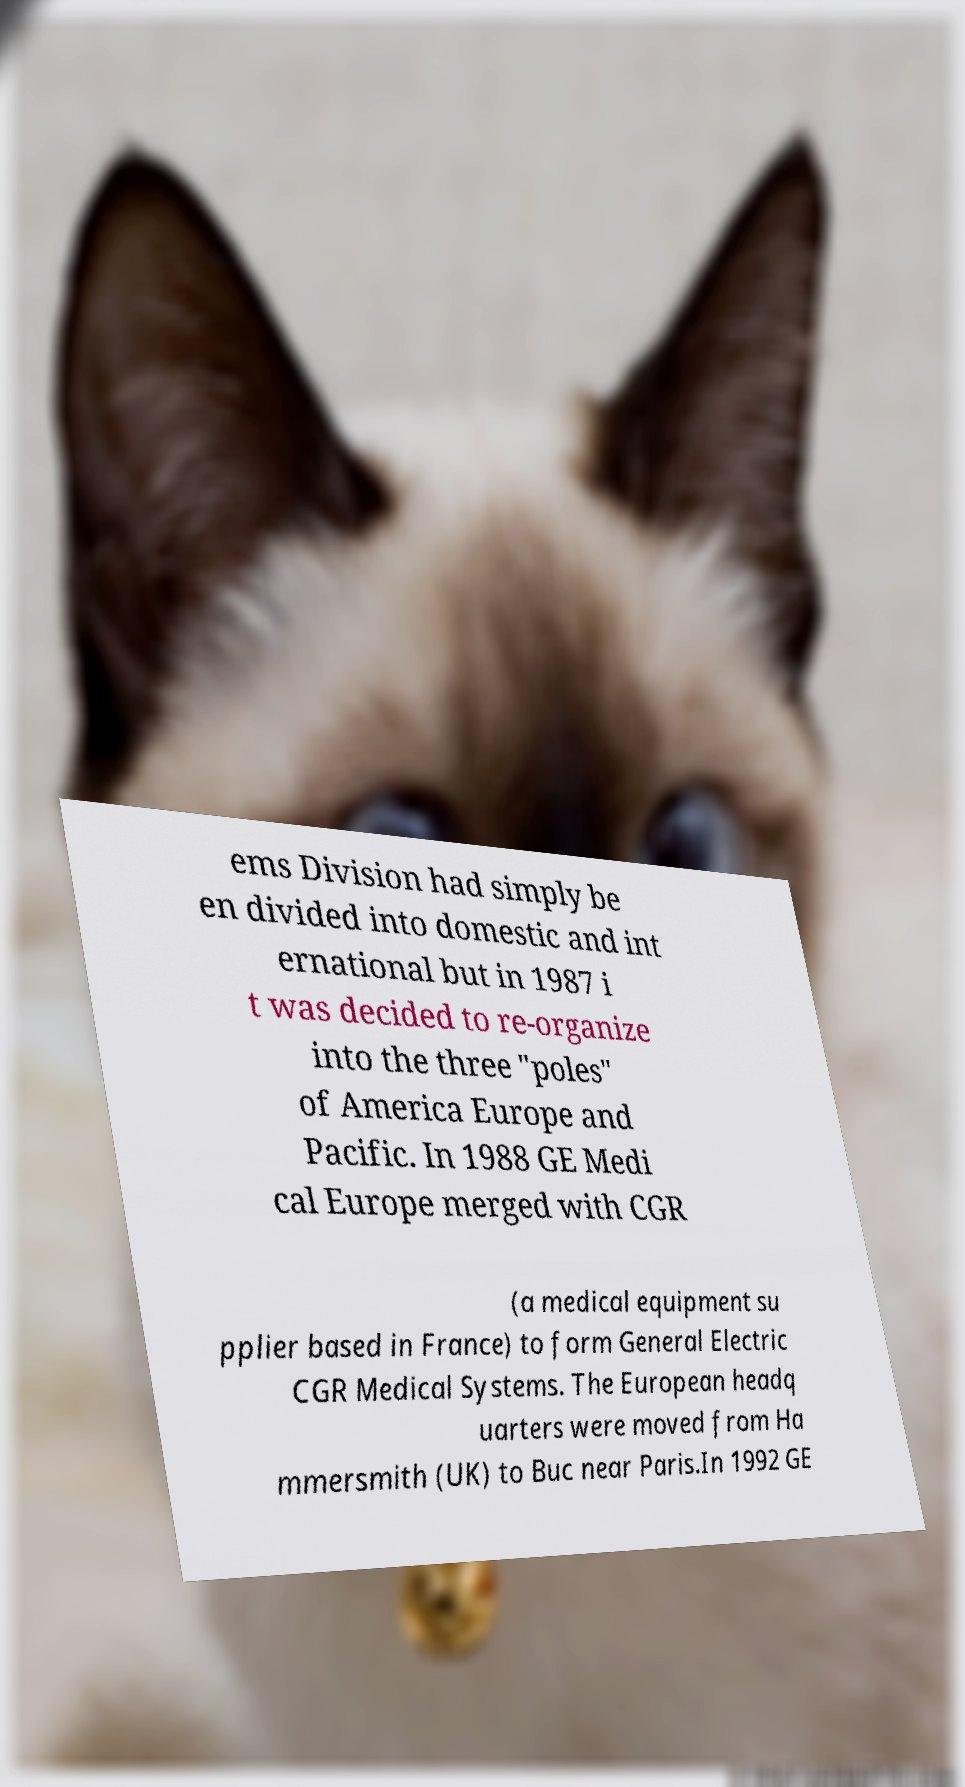Please identify and transcribe the text found in this image. ems Division had simply be en divided into domestic and int ernational but in 1987 i t was decided to re-organize into the three "poles" of America Europe and Pacific. In 1988 GE Medi cal Europe merged with CGR (a medical equipment su pplier based in France) to form General Electric CGR Medical Systems. The European headq uarters were moved from Ha mmersmith (UK) to Buc near Paris.In 1992 GE 